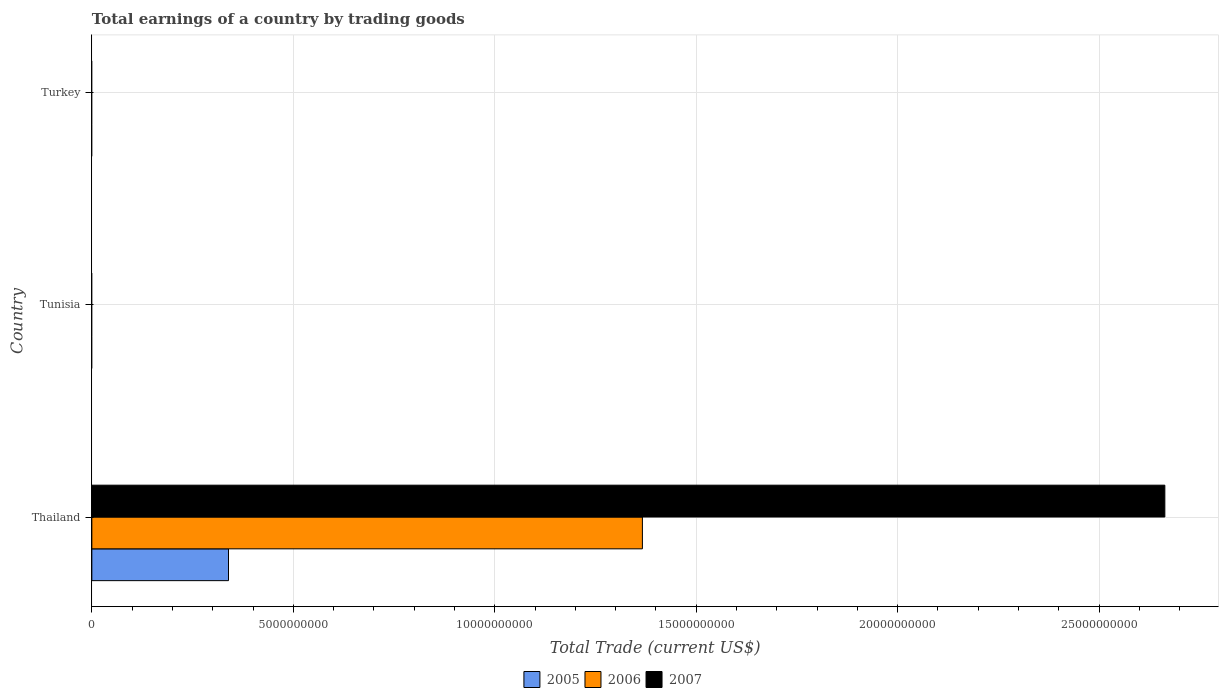How many bars are there on the 3rd tick from the bottom?
Ensure brevity in your answer.  0. What is the label of the 1st group of bars from the top?
Offer a terse response. Turkey. In how many cases, is the number of bars for a given country not equal to the number of legend labels?
Offer a very short reply. 2. What is the total earnings in 2007 in Tunisia?
Your answer should be very brief. 0. Across all countries, what is the maximum total earnings in 2006?
Keep it short and to the point. 1.37e+1. In which country was the total earnings in 2007 maximum?
Ensure brevity in your answer.  Thailand. What is the total total earnings in 2006 in the graph?
Offer a terse response. 1.37e+1. What is the difference between the total earnings in 2005 in Thailand and the total earnings in 2006 in Tunisia?
Offer a terse response. 3.39e+09. What is the average total earnings in 2006 per country?
Make the answer very short. 4.55e+09. What is the difference between the total earnings in 2006 and total earnings in 2007 in Thailand?
Your response must be concise. -1.30e+1. What is the difference between the highest and the lowest total earnings in 2006?
Provide a succinct answer. 1.37e+1. In how many countries, is the total earnings in 2007 greater than the average total earnings in 2007 taken over all countries?
Offer a very short reply. 1. Is it the case that in every country, the sum of the total earnings in 2006 and total earnings in 2007 is greater than the total earnings in 2005?
Your answer should be very brief. No. How many countries are there in the graph?
Your answer should be compact. 3. Where does the legend appear in the graph?
Provide a succinct answer. Bottom center. How many legend labels are there?
Provide a short and direct response. 3. What is the title of the graph?
Offer a terse response. Total earnings of a country by trading goods. What is the label or title of the X-axis?
Your response must be concise. Total Trade (current US$). What is the Total Trade (current US$) of 2005 in Thailand?
Offer a very short reply. 3.39e+09. What is the Total Trade (current US$) of 2006 in Thailand?
Offer a very short reply. 1.37e+1. What is the Total Trade (current US$) in 2007 in Thailand?
Provide a succinct answer. 2.66e+1. What is the Total Trade (current US$) in 2006 in Tunisia?
Give a very brief answer. 0. What is the Total Trade (current US$) in 2007 in Tunisia?
Keep it short and to the point. 0. Across all countries, what is the maximum Total Trade (current US$) of 2005?
Provide a short and direct response. 3.39e+09. Across all countries, what is the maximum Total Trade (current US$) of 2006?
Ensure brevity in your answer.  1.37e+1. Across all countries, what is the maximum Total Trade (current US$) of 2007?
Offer a very short reply. 2.66e+1. Across all countries, what is the minimum Total Trade (current US$) of 2006?
Offer a terse response. 0. Across all countries, what is the minimum Total Trade (current US$) of 2007?
Give a very brief answer. 0. What is the total Total Trade (current US$) of 2005 in the graph?
Your answer should be very brief. 3.39e+09. What is the total Total Trade (current US$) in 2006 in the graph?
Your response must be concise. 1.37e+1. What is the total Total Trade (current US$) of 2007 in the graph?
Give a very brief answer. 2.66e+1. What is the average Total Trade (current US$) of 2005 per country?
Your answer should be compact. 1.13e+09. What is the average Total Trade (current US$) in 2006 per country?
Your response must be concise. 4.55e+09. What is the average Total Trade (current US$) of 2007 per country?
Offer a very short reply. 8.88e+09. What is the difference between the Total Trade (current US$) in 2005 and Total Trade (current US$) in 2006 in Thailand?
Ensure brevity in your answer.  -1.03e+1. What is the difference between the Total Trade (current US$) in 2005 and Total Trade (current US$) in 2007 in Thailand?
Your response must be concise. -2.32e+1. What is the difference between the Total Trade (current US$) of 2006 and Total Trade (current US$) of 2007 in Thailand?
Keep it short and to the point. -1.30e+1. What is the difference between the highest and the lowest Total Trade (current US$) in 2005?
Offer a very short reply. 3.39e+09. What is the difference between the highest and the lowest Total Trade (current US$) in 2006?
Provide a short and direct response. 1.37e+1. What is the difference between the highest and the lowest Total Trade (current US$) of 2007?
Your answer should be compact. 2.66e+1. 